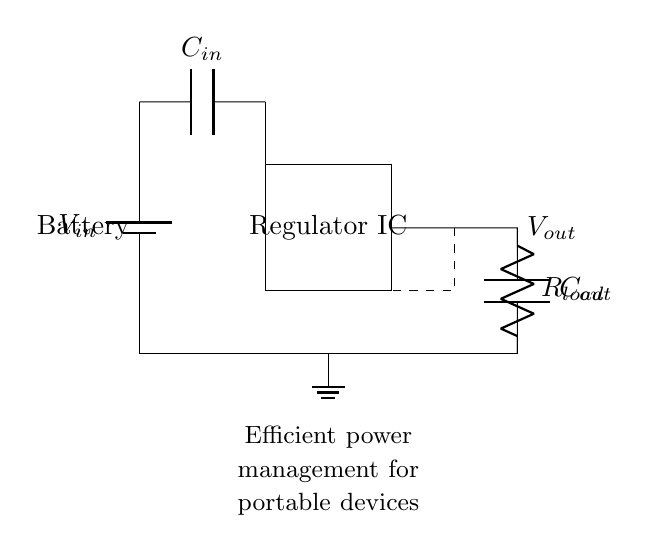What component regulates the output voltage? The regulator IC is responsible for controlling and maintaining the voltage output. It is designed to adjust the output voltage based on load and input conditions.
Answer: Regulator IC What is the role of the capacitor labeled C in the input section? The input capacitor, C_in, filters and smooths the input voltage from the battery to ensure stable operation of the voltage regulator. This helps to reduce voltage spikes and maintains a steady supply.
Answer: Filtering What is the load resistance value in this circuit? The load resistance, represented by R_load, determines how much current the output can provide to the load. It's an essential part of calculating current flow but the exact value isn't specified in the diagram.
Answer: R_load What happens to the efficiency when the output load increases? When the output load increases, the efficiency of the voltage regulator can decrease due to higher power dissipation in the form of heat. The regulator must work harder to maintain the output voltage which can reduce overall performance.
Answer: Decreases What is the function of the output capacitor in this circuit? The output capacitor, C_out, helps stabilize the output voltage and reduce fluctuations during load changes. It acts as a reservoir, providing additional charge when demand increases quickly.
Answer: Stabilization 